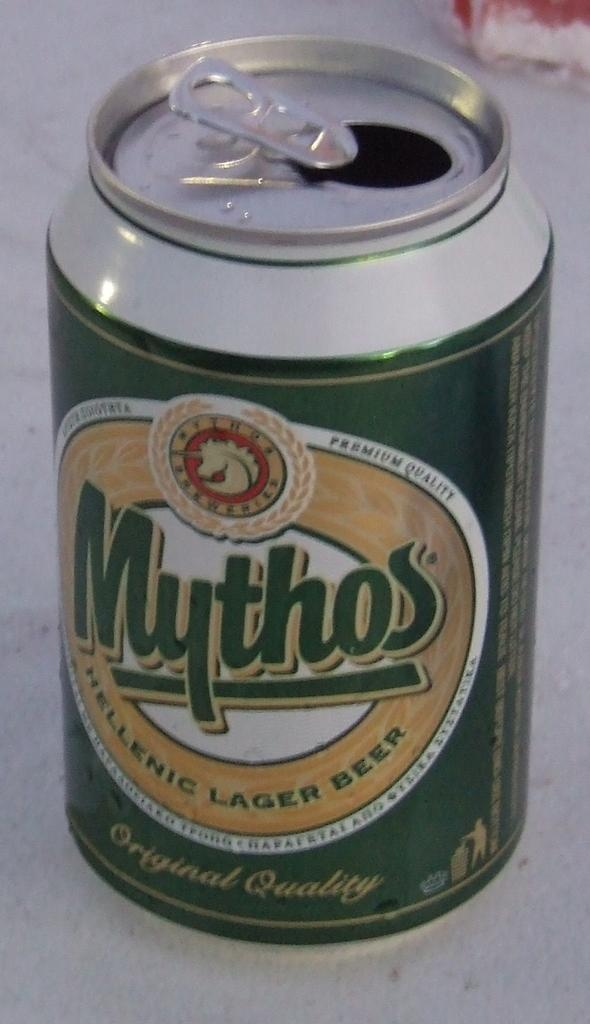<image>
Present a compact description of the photo's key features. A green beer can says Mythos Hellenic Lager Beer. 